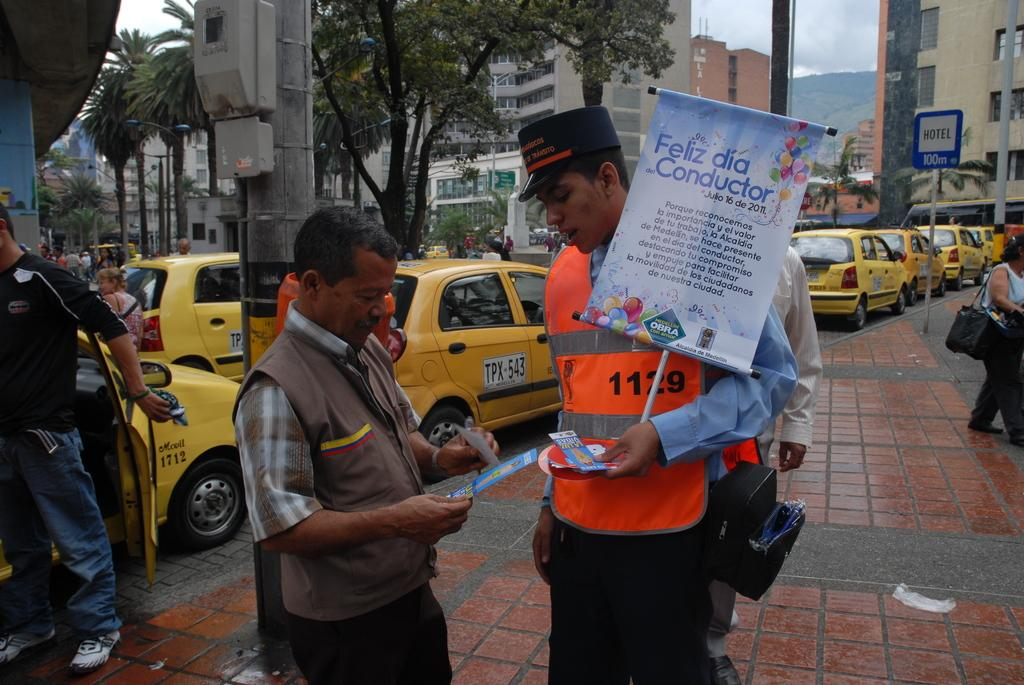<image>
Share a concise interpretation of the image provided. An officer is holding a sign that says feliz dia constructor. 